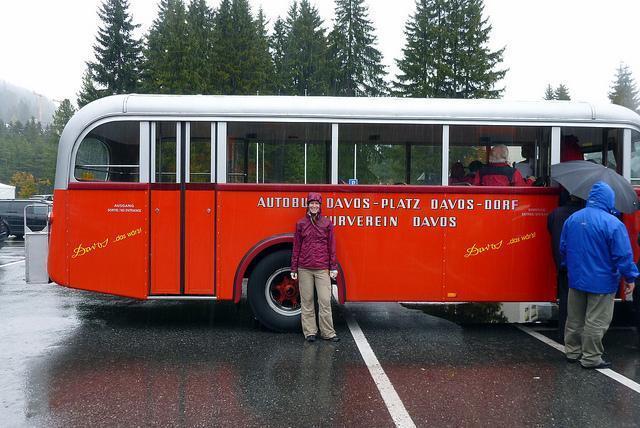How many people can you see?
Give a very brief answer. 2. How many umbrellas are visible?
Give a very brief answer. 1. How many bears are reflected on the water?
Give a very brief answer. 0. 